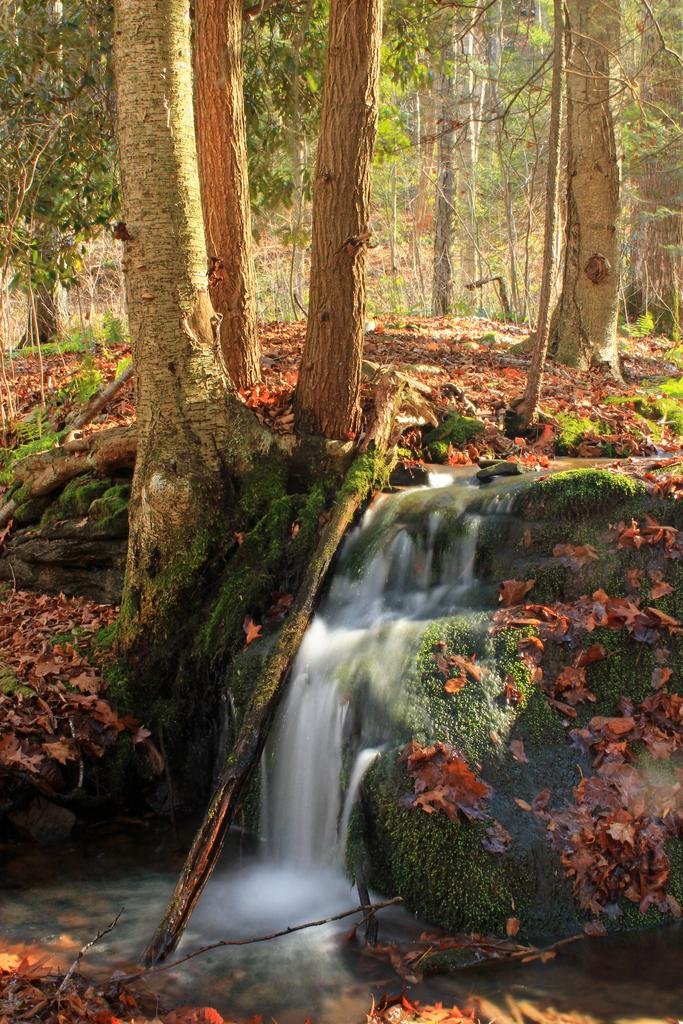Where was the picture taken? The picture was clicked outside. What can be seen in the foreground of the image? There is a water body and a waterfall in the foreground of the image. What type of vegetation is visible in the background of the image? There are trees in the background of the image. What else can be seen in the background of the image? There are other unspecified items in the background of the image. What type of yoke is being used to carry the art in the image? There is no yoke or art present in the image. How is the wax being used in the image? There is no wax present in the image. 